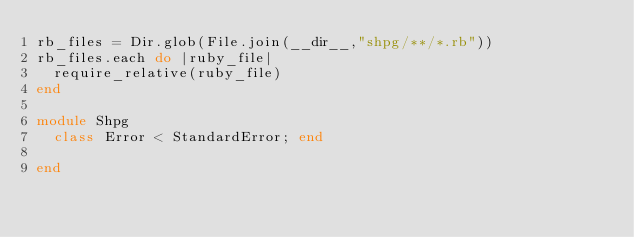<code> <loc_0><loc_0><loc_500><loc_500><_Ruby_>rb_files = Dir.glob(File.join(__dir__,"shpg/**/*.rb"))
rb_files.each do |ruby_file|
	require_relative(ruby_file)
end

module Shpg
  class Error < StandardError; end

end
</code> 